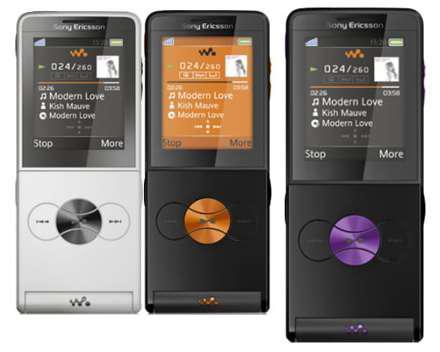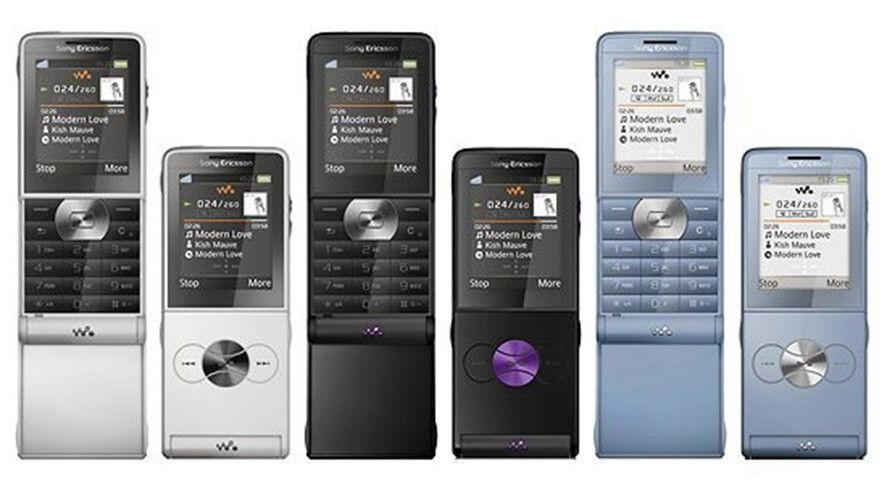The first image is the image on the left, the second image is the image on the right. Evaluate the accuracy of this statement regarding the images: "One of the pictures shows at least six phones side by side.". Is it true? Answer yes or no. Yes. The first image is the image on the left, the second image is the image on the right. Examine the images to the left and right. Is the description "One image shows exactly three phones, and the other image shows a single row containing at least four phones." accurate? Answer yes or no. Yes. 